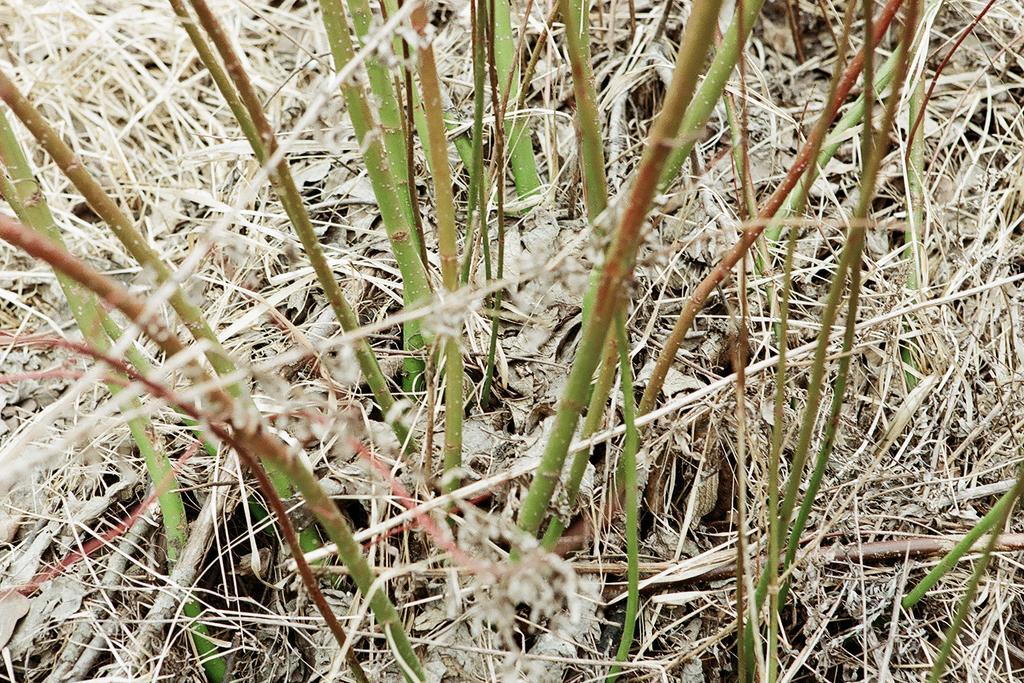In one or two sentences, can you explain what this image depicts? In this image we can see lawn straw and there are plants. 